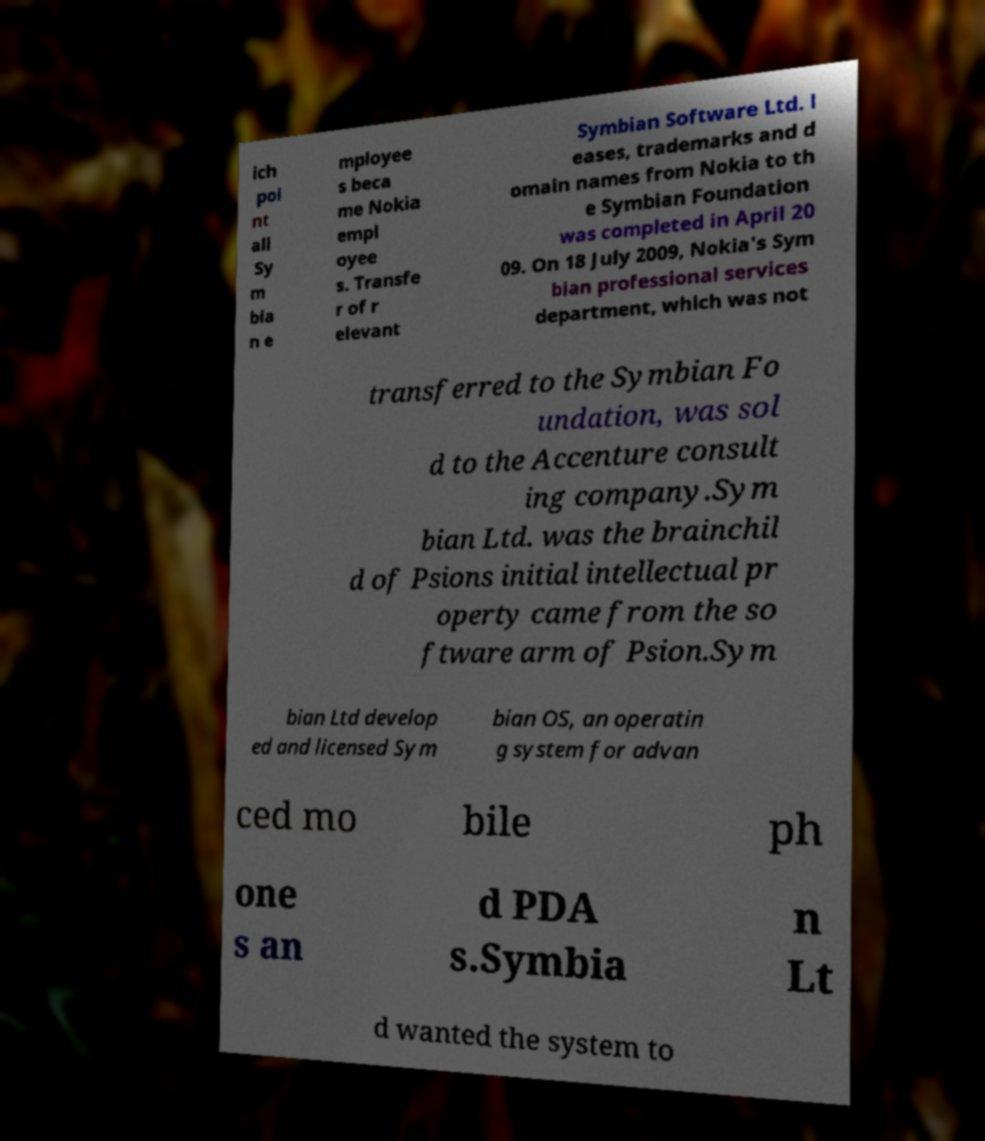Please identify and transcribe the text found in this image. ich poi nt all Sy m bia n e mployee s beca me Nokia empl oyee s. Transfe r of r elevant Symbian Software Ltd. l eases, trademarks and d omain names from Nokia to th e Symbian Foundation was completed in April 20 09. On 18 July 2009, Nokia's Sym bian professional services department, which was not transferred to the Symbian Fo undation, was sol d to the Accenture consult ing company.Sym bian Ltd. was the brainchil d of Psions initial intellectual pr operty came from the so ftware arm of Psion.Sym bian Ltd develop ed and licensed Sym bian OS, an operatin g system for advan ced mo bile ph one s an d PDA s.Symbia n Lt d wanted the system to 